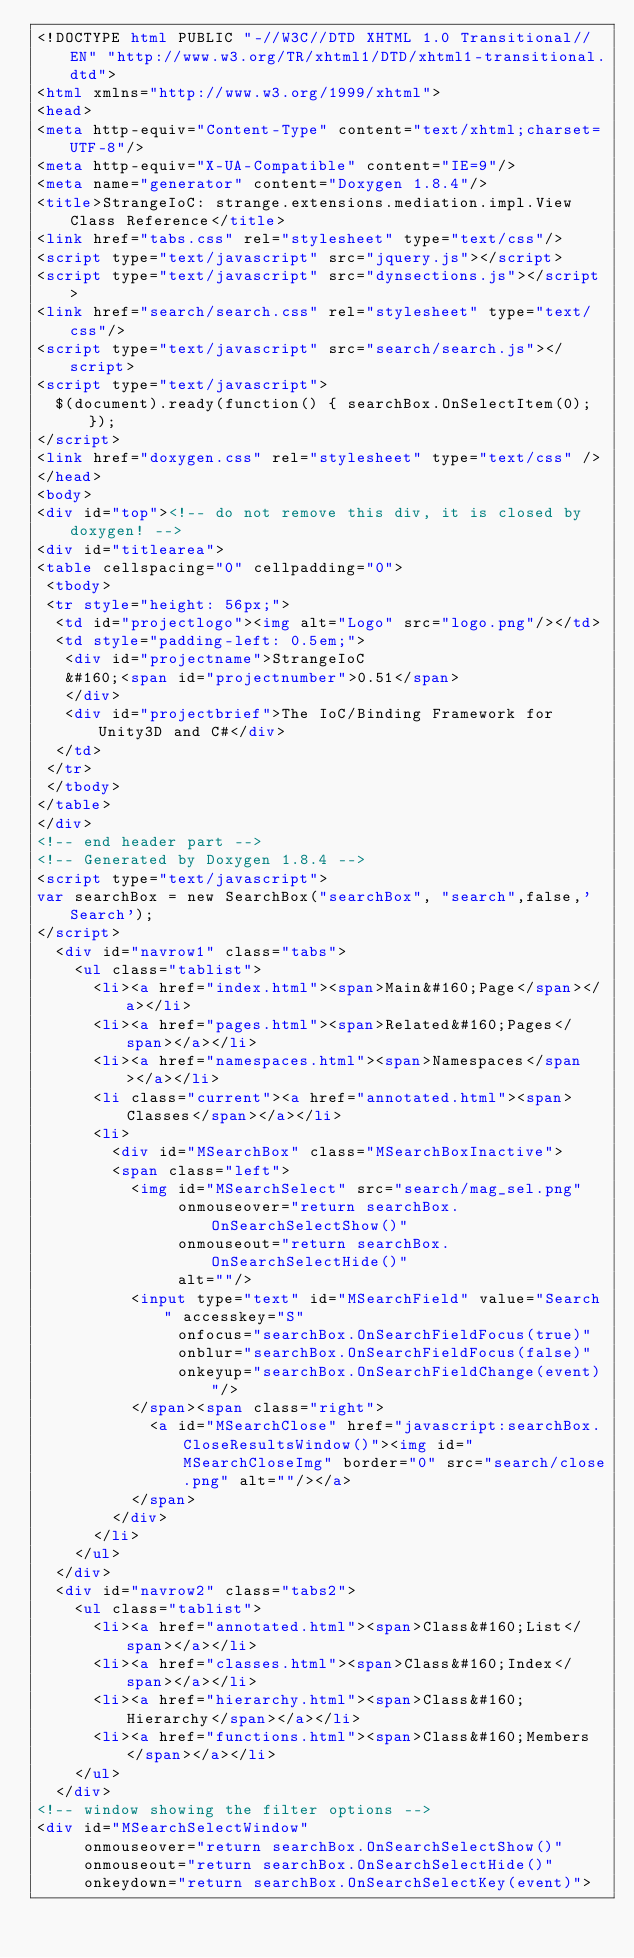<code> <loc_0><loc_0><loc_500><loc_500><_HTML_><!DOCTYPE html PUBLIC "-//W3C//DTD XHTML 1.0 Transitional//EN" "http://www.w3.org/TR/xhtml1/DTD/xhtml1-transitional.dtd">
<html xmlns="http://www.w3.org/1999/xhtml">
<head>
<meta http-equiv="Content-Type" content="text/xhtml;charset=UTF-8"/>
<meta http-equiv="X-UA-Compatible" content="IE=9"/>
<meta name="generator" content="Doxygen 1.8.4"/>
<title>StrangeIoC: strange.extensions.mediation.impl.View Class Reference</title>
<link href="tabs.css" rel="stylesheet" type="text/css"/>
<script type="text/javascript" src="jquery.js"></script>
<script type="text/javascript" src="dynsections.js"></script>
<link href="search/search.css" rel="stylesheet" type="text/css"/>
<script type="text/javascript" src="search/search.js"></script>
<script type="text/javascript">
  $(document).ready(function() { searchBox.OnSelectItem(0); });
</script>
<link href="doxygen.css" rel="stylesheet" type="text/css" />
</head>
<body>
<div id="top"><!-- do not remove this div, it is closed by doxygen! -->
<div id="titlearea">
<table cellspacing="0" cellpadding="0">
 <tbody>
 <tr style="height: 56px;">
  <td id="projectlogo"><img alt="Logo" src="logo.png"/></td>
  <td style="padding-left: 0.5em;">
   <div id="projectname">StrangeIoC
   &#160;<span id="projectnumber">0.51</span>
   </div>
   <div id="projectbrief">The IoC/Binding Framework for Unity3D and C#</div>
  </td>
 </tr>
 </tbody>
</table>
</div>
<!-- end header part -->
<!-- Generated by Doxygen 1.8.4 -->
<script type="text/javascript">
var searchBox = new SearchBox("searchBox", "search",false,'Search');
</script>
  <div id="navrow1" class="tabs">
    <ul class="tablist">
      <li><a href="index.html"><span>Main&#160;Page</span></a></li>
      <li><a href="pages.html"><span>Related&#160;Pages</span></a></li>
      <li><a href="namespaces.html"><span>Namespaces</span></a></li>
      <li class="current"><a href="annotated.html"><span>Classes</span></a></li>
      <li>
        <div id="MSearchBox" class="MSearchBoxInactive">
        <span class="left">
          <img id="MSearchSelect" src="search/mag_sel.png"
               onmouseover="return searchBox.OnSearchSelectShow()"
               onmouseout="return searchBox.OnSearchSelectHide()"
               alt=""/>
          <input type="text" id="MSearchField" value="Search" accesskey="S"
               onfocus="searchBox.OnSearchFieldFocus(true)" 
               onblur="searchBox.OnSearchFieldFocus(false)" 
               onkeyup="searchBox.OnSearchFieldChange(event)"/>
          </span><span class="right">
            <a id="MSearchClose" href="javascript:searchBox.CloseResultsWindow()"><img id="MSearchCloseImg" border="0" src="search/close.png" alt=""/></a>
          </span>
        </div>
      </li>
    </ul>
  </div>
  <div id="navrow2" class="tabs2">
    <ul class="tablist">
      <li><a href="annotated.html"><span>Class&#160;List</span></a></li>
      <li><a href="classes.html"><span>Class&#160;Index</span></a></li>
      <li><a href="hierarchy.html"><span>Class&#160;Hierarchy</span></a></li>
      <li><a href="functions.html"><span>Class&#160;Members</span></a></li>
    </ul>
  </div>
<!-- window showing the filter options -->
<div id="MSearchSelectWindow"
     onmouseover="return searchBox.OnSearchSelectShow()"
     onmouseout="return searchBox.OnSearchSelectHide()"
     onkeydown="return searchBox.OnSearchSelectKey(event)"></code> 